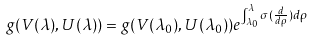Convert formula to latex. <formula><loc_0><loc_0><loc_500><loc_500>g ( V ( \lambda ) , U ( \lambda ) ) = g ( V ( \lambda _ { 0 } ) , U ( \lambda _ { 0 } ) ) e ^ { \int _ { \lambda _ { 0 } } ^ { \lambda } \sigma ( \frac { d } { d \rho } ) d \rho }</formula> 